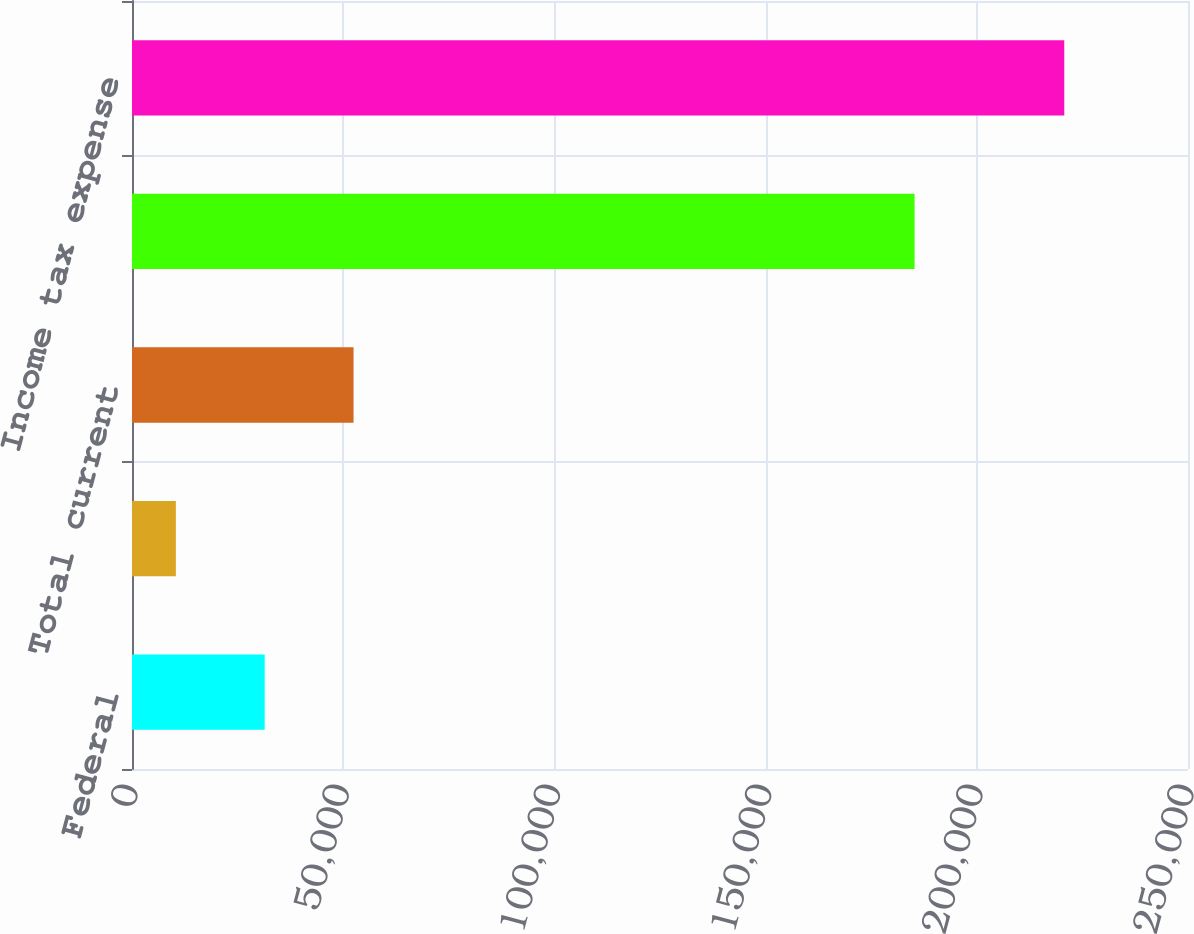Convert chart to OTSL. <chart><loc_0><loc_0><loc_500><loc_500><bar_chart><fcel>Federal<fcel>State<fcel>Total current<fcel>Total deferred<fcel>Income tax expense<nl><fcel>31414.3<fcel>10382<fcel>52446.6<fcel>185269<fcel>220705<nl></chart> 